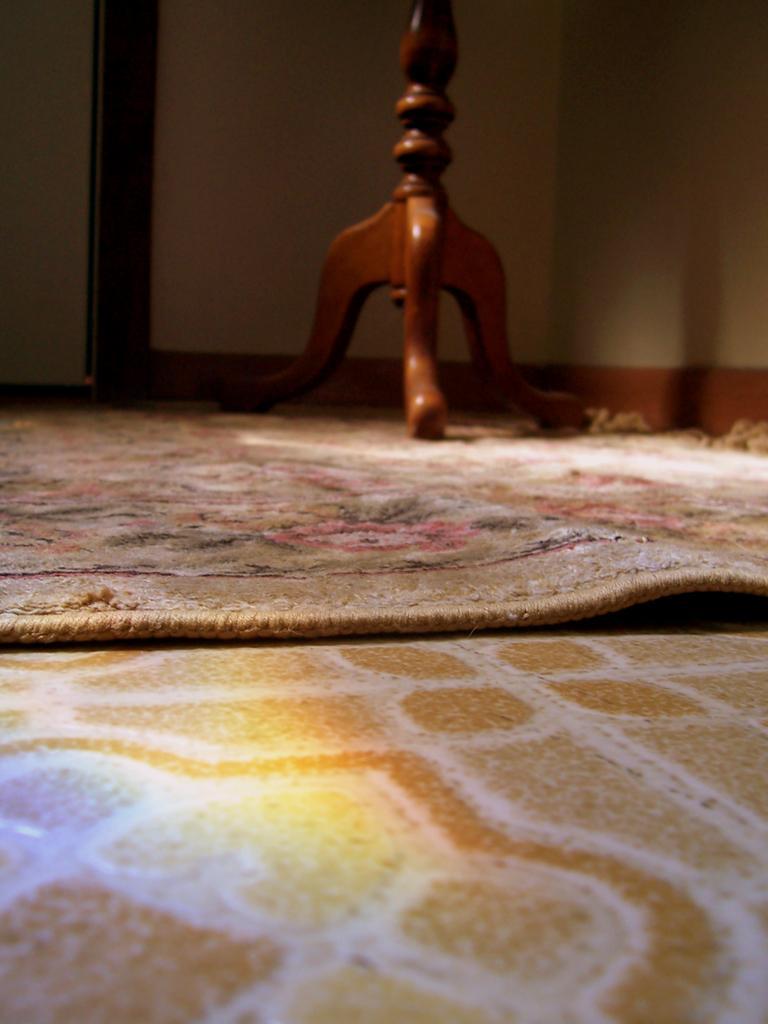Can you describe this image briefly? This picture is clicked inside. In the foreground we can see the floor and the floor mat. In the background there is a wall and a wooden object placed on the ground. 